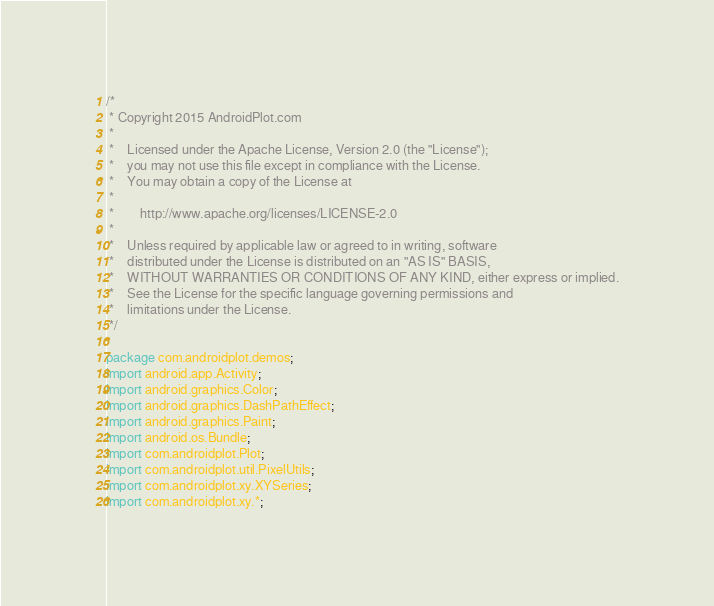<code> <loc_0><loc_0><loc_500><loc_500><_Java_>/*
 * Copyright 2015 AndroidPlot.com
 *
 *    Licensed under the Apache License, Version 2.0 (the "License");
 *    you may not use this file except in compliance with the License.
 *    You may obtain a copy of the License at
 *
 *        http://www.apache.org/licenses/LICENSE-2.0
 *
 *    Unless required by applicable law or agreed to in writing, software
 *    distributed under the License is distributed on an "AS IS" BASIS,
 *    WITHOUT WARRANTIES OR CONDITIONS OF ANY KIND, either express or implied.
 *    See the License for the specific language governing permissions and
 *    limitations under the License.
 */

package com.androidplot.demos;
import android.app.Activity;
import android.graphics.Color;
import android.graphics.DashPathEffect;
import android.graphics.Paint;
import android.os.Bundle;
import com.androidplot.Plot;
import com.androidplot.util.PixelUtils;
import com.androidplot.xy.XYSeries;
import com.androidplot.xy.*;
</code> 